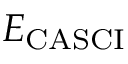Convert formula to latex. <formula><loc_0><loc_0><loc_500><loc_500>E _ { C A S C I }</formula> 